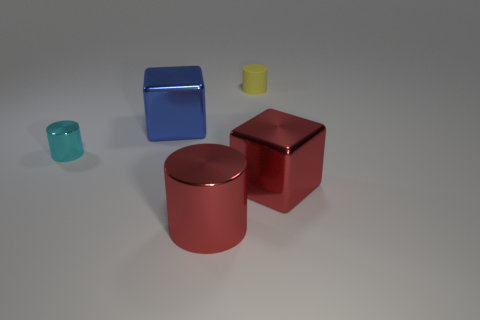Do the big red object that is right of the rubber object and the big cylinder have the same material? yes 